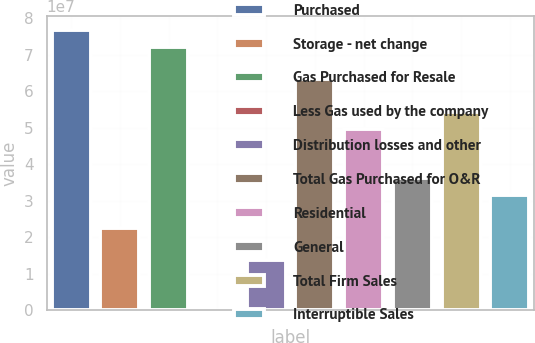<chart> <loc_0><loc_0><loc_500><loc_500><bar_chart><fcel>Purchased<fcel>Storage - net change<fcel>Gas Purchased for Resale<fcel>Less Gas used by the company<fcel>Distribution losses and other<fcel>Total Gas Purchased for O&R<fcel>Residential<fcel>General<fcel>Total Firm Sales<fcel>Interruptible Sales<nl><fcel>7.67255e+07<fcel>2.26065e+07<fcel>7.22155e+07<fcel>56939<fcel>1.35867e+07<fcel>6.31957e+07<fcel>4.9666e+07<fcel>3.61362e+07<fcel>5.41759e+07<fcel>3.16263e+07<nl></chart> 